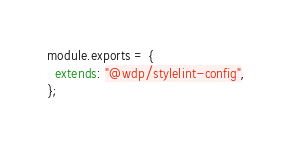<code> <loc_0><loc_0><loc_500><loc_500><_JavaScript_>module.exports = {
  extends: "@wdp/stylelint-config",
};
</code> 